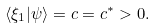Convert formula to latex. <formula><loc_0><loc_0><loc_500><loc_500>\langle \xi _ { 1 } | \psi \rangle = c = c ^ { * } > 0 .</formula> 